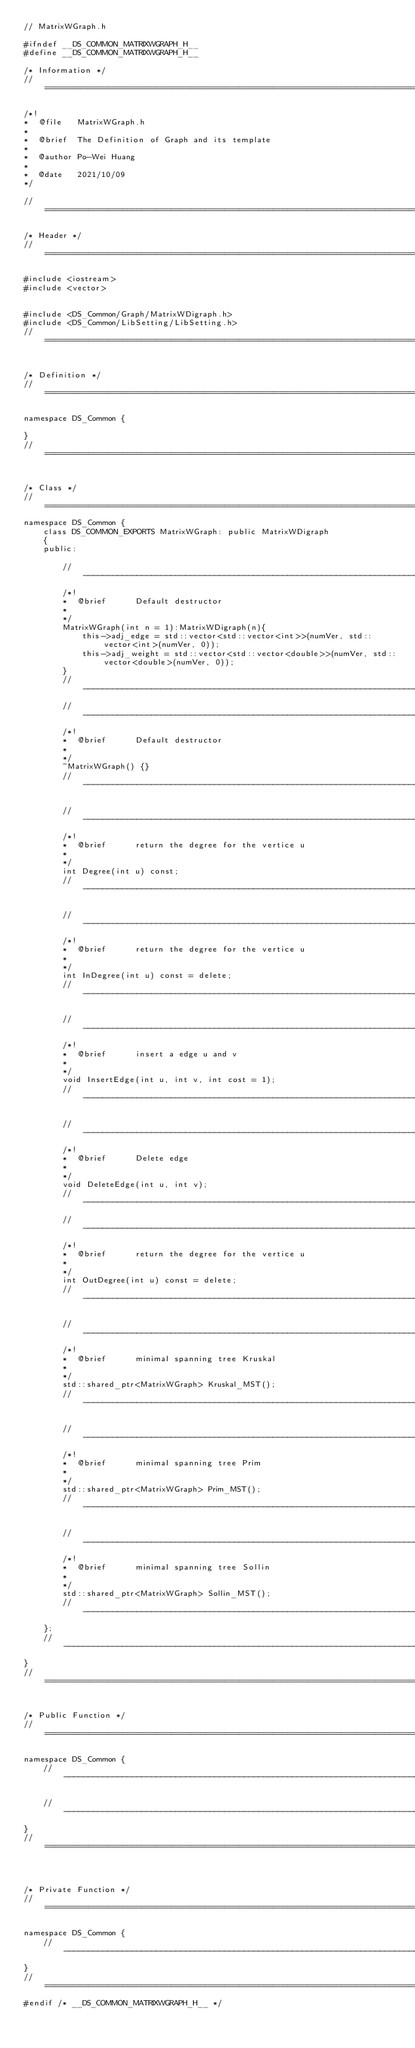<code> <loc_0><loc_0><loc_500><loc_500><_C_>// MatrixWGraph.h

#ifndef __DS_COMMON_MATRIXWGRAPH_H__
#define __DS_COMMON_MATRIXWGRAPH_H__

/* Information */
//====================================================================================================

/*!
*  @file   MatrixWGraph.h
*
*  @brief  The Definition of Graph and its template
*
*  @author Po-Wei Huang
*
*  @date   2021/10/09
*/

//====================================================================================================

/* Header */
//====================================================================================================

#include <iostream>
#include <vector>


#include <DS_Common/Graph/MatrixWDigraph.h>
#include <DS_Common/LibSetting/LibSetting.h>
//====================================================================================================


/* Definition */
//====================================================================================================

namespace DS_Common {

}
//====================================================================================================


/* Class */
//====================================================================================================
namespace DS_Common {
	class DS_COMMON_EXPORTS MatrixWGraph: public MatrixWDigraph
	{
	public:

		//-----------------------------------------------------------------------------------------
		/*!
		*  @brief      Default destructor
		*
		*/
		MatrixWGraph(int n = 1):MatrixWDigraph(n){
			this->adj_edge = std::vector<std::vector<int>>(numVer, std::vector<int>(numVer, 0));
			this->adj_weight = std::vector<std::vector<double>>(numVer, std::vector<double>(numVer, 0));
		}
		//-----------------------------------------------------------------------------------------
		//-----------------------------------------------------------------------------------------
		/*!
		*  @brief      Default destructor
		*
		*/
		~MatrixWGraph() {}
		//-----------------------------------------------------------------------------------------

		//-----------------------------------------------------------------------------------------
		/*!
		*  @brief      return the degree for the vertice u
		*
		*/
		int Degree(int u) const;
		//-----------------------------------------------------------------------------------------

		//-----------------------------------------------------------------------------------------
		/*!
		*  @brief      return the degree for the vertice u
		*
		*/
		int InDegree(int u) const = delete;
		//-----------------------------------------------------------------------------------------

		//-----------------------------------------------------------------------------------------
		/*!
		*  @brief      insert a edge u and v
		*
		*/
		void InsertEdge(int u, int v, int cost = 1);
		//-----------------------------------------------------------------------------------------

		//-----------------------------------------------------------------------------------------
		/*!
		*  @brief      Delete edge
		*
		*/
		void DeleteEdge(int u, int v);
		//-----------------------------------------------------------------------------------------
		//-----------------------------------------------------------------------------------------
		/*!
		*  @brief      return the degree for the vertice u
		*
		*/
		int OutDegree(int u) const = delete;
		//-----------------------------------------------------------------------------------------

		//-----------------------------------------------------------------------------------------
		/*!
		*  @brief      minimal spanning tree Kruskal
		*
		*/
		std::shared_ptr<MatrixWGraph> Kruskal_MST();
		//-----------------------------------------------------------------------------------------

		//-----------------------------------------------------------------------------------------
		/*!
		*  @brief      minimal spanning tree Prim
		*
		*/
		std::shared_ptr<MatrixWGraph> Prim_MST();
		//-----------------------------------------------------------------------------------------

		//-----------------------------------------------------------------------------------------
		/*!
		*  @brief      minimal spanning tree Sollin
		*
		*/
		std::shared_ptr<MatrixWGraph> Sollin_MST();
		//-----------------------------------------------------------------------------------------
	};
	//--------------------------------------------------------------------------------------------
}
//====================================================================================================


/* Public Function */
//====================================================================================================

namespace DS_Common {
	//-----------------------------------------------------------------------------------------

	//-----------------------------------------------------------------------------------------
}
//====================================================================================================



/* Private Function */
//====================================================================================================

namespace DS_Common {
	//-----------------------------------------------------------------------------------------
}
//====================================================================================================
#endif /* __DS_COMMON_MATRIXWGRAPH_H__ */
</code> 